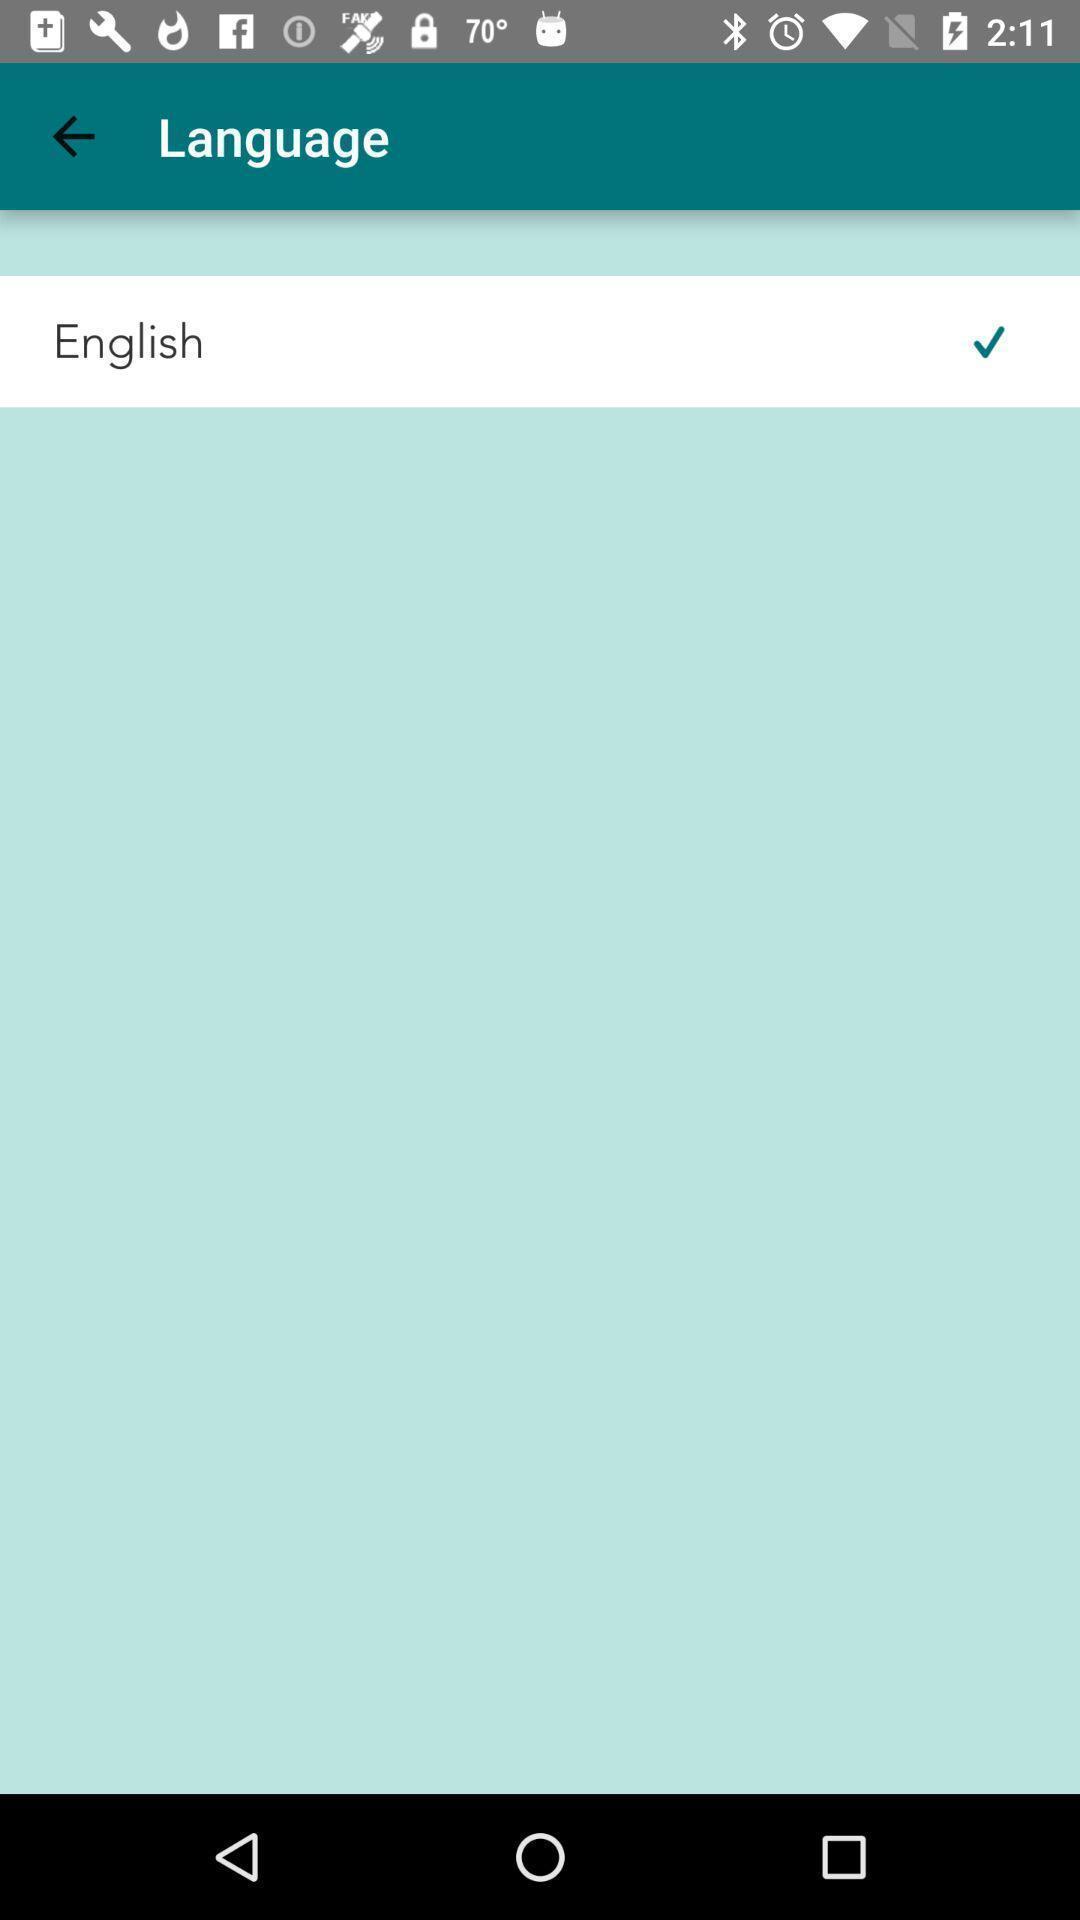Describe the content in this image. Screen displaying about language settings. 